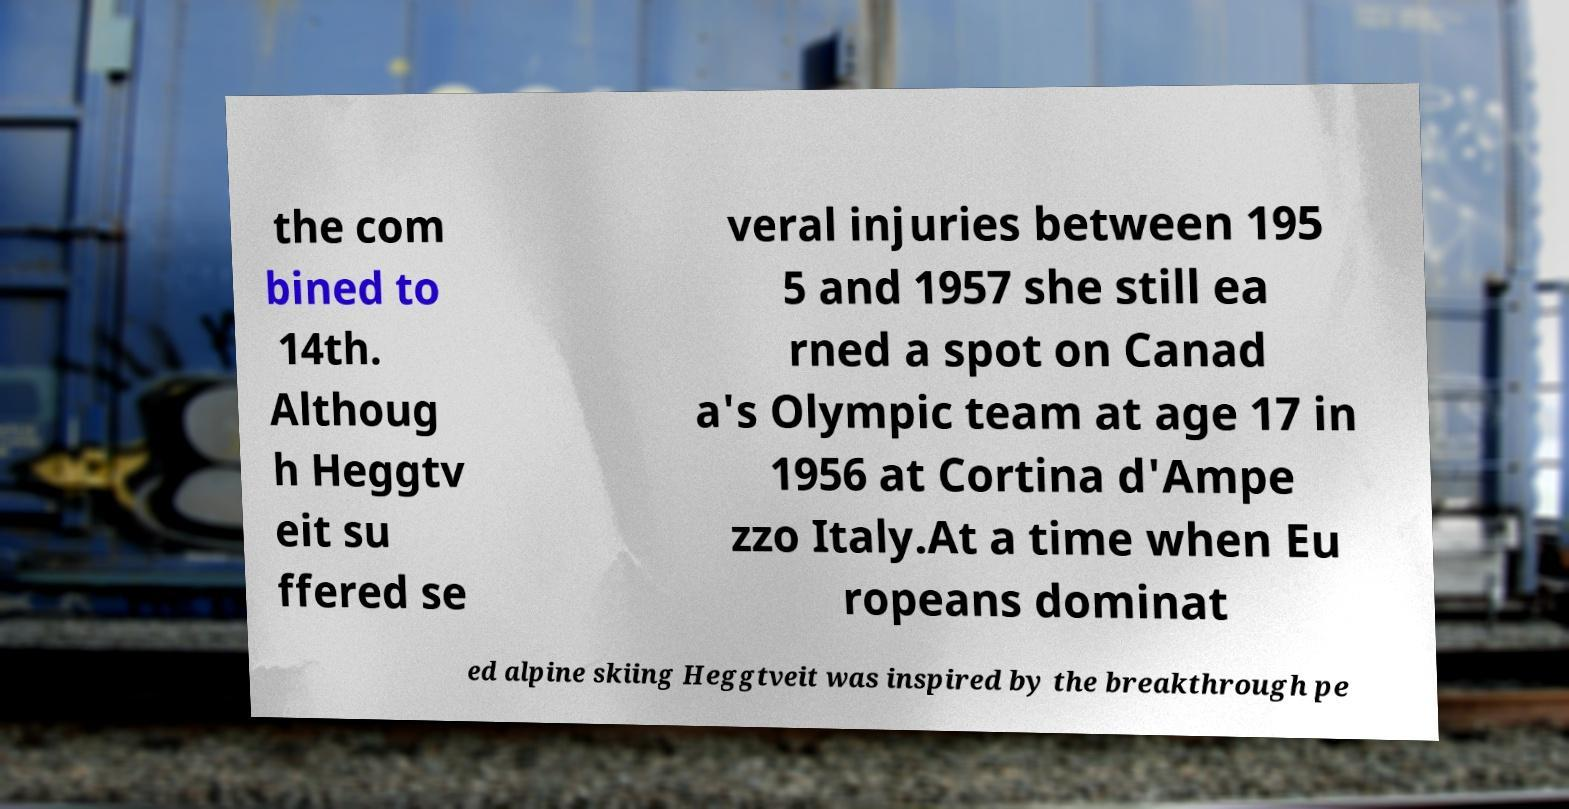Can you accurately transcribe the text from the provided image for me? the com bined to 14th. Althoug h Heggtv eit su ffered se veral injuries between 195 5 and 1957 she still ea rned a spot on Canad a's Olympic team at age 17 in 1956 at Cortina d'Ampe zzo Italy.At a time when Eu ropeans dominat ed alpine skiing Heggtveit was inspired by the breakthrough pe 